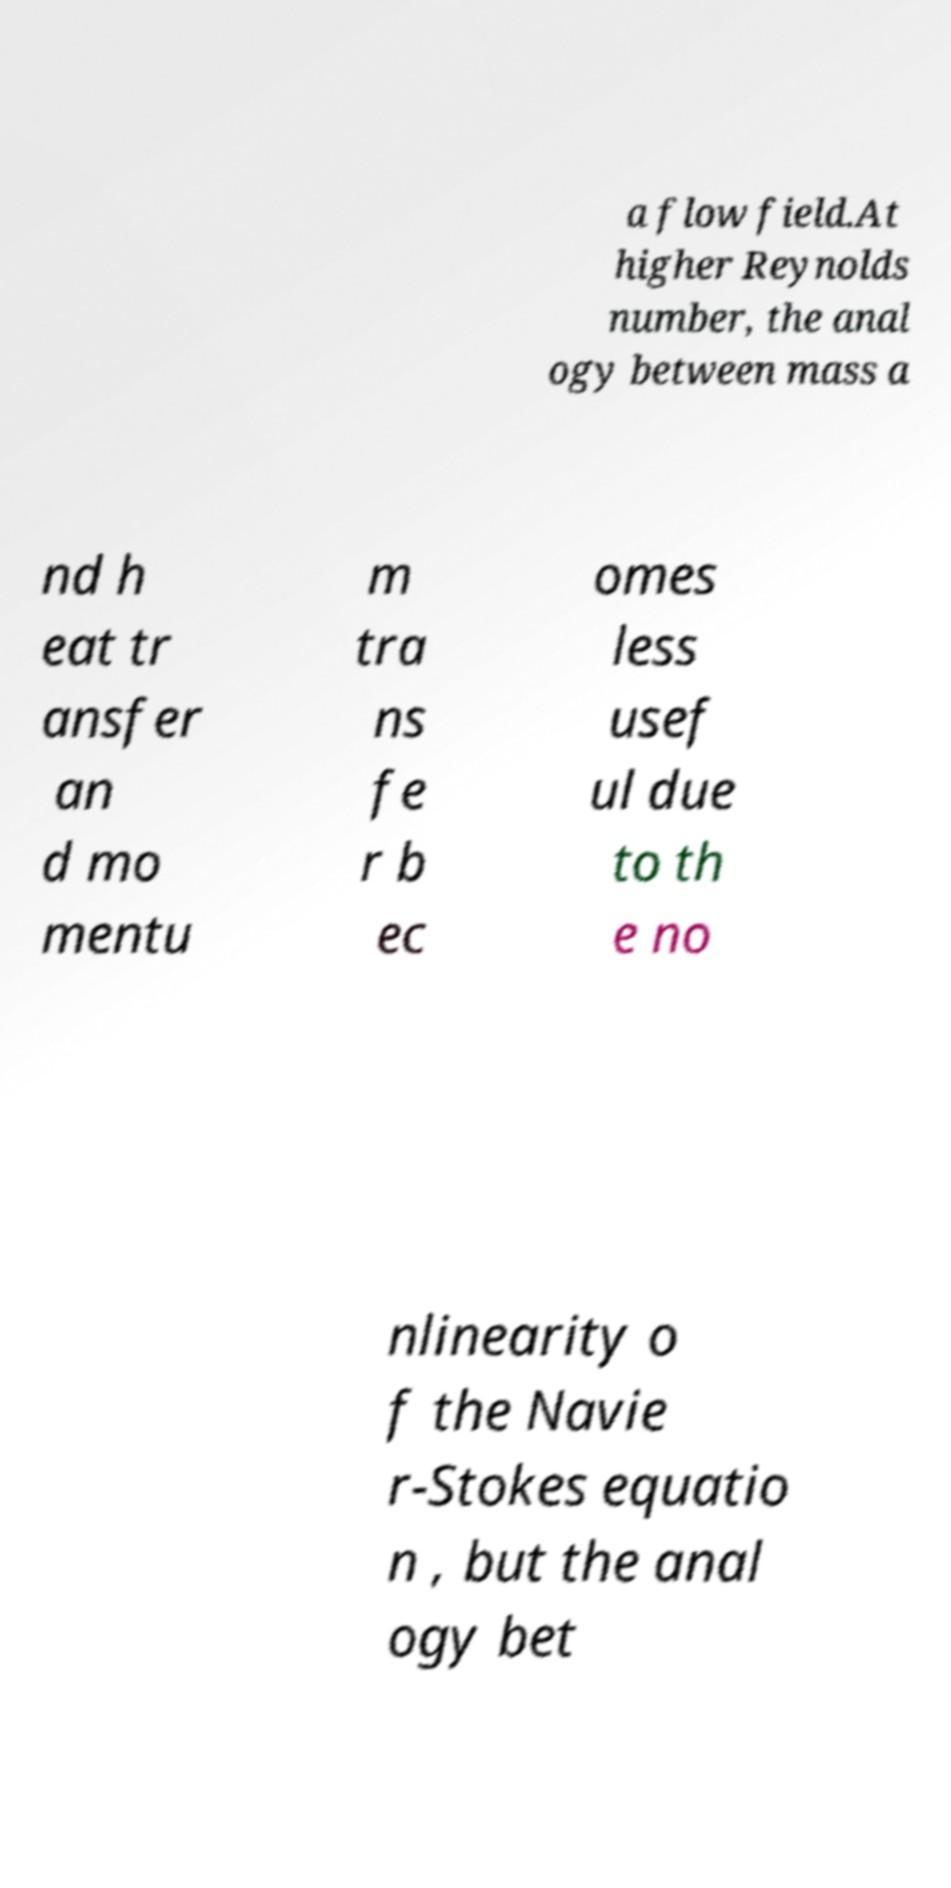There's text embedded in this image that I need extracted. Can you transcribe it verbatim? a flow field.At higher Reynolds number, the anal ogy between mass a nd h eat tr ansfer an d mo mentu m tra ns fe r b ec omes less usef ul due to th e no nlinearity o f the Navie r-Stokes equatio n , but the anal ogy bet 